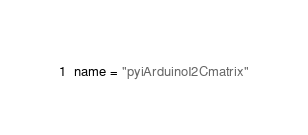<code> <loc_0><loc_0><loc_500><loc_500><_Python_>name = "pyiArduinoI2Cmatrix"
</code> 